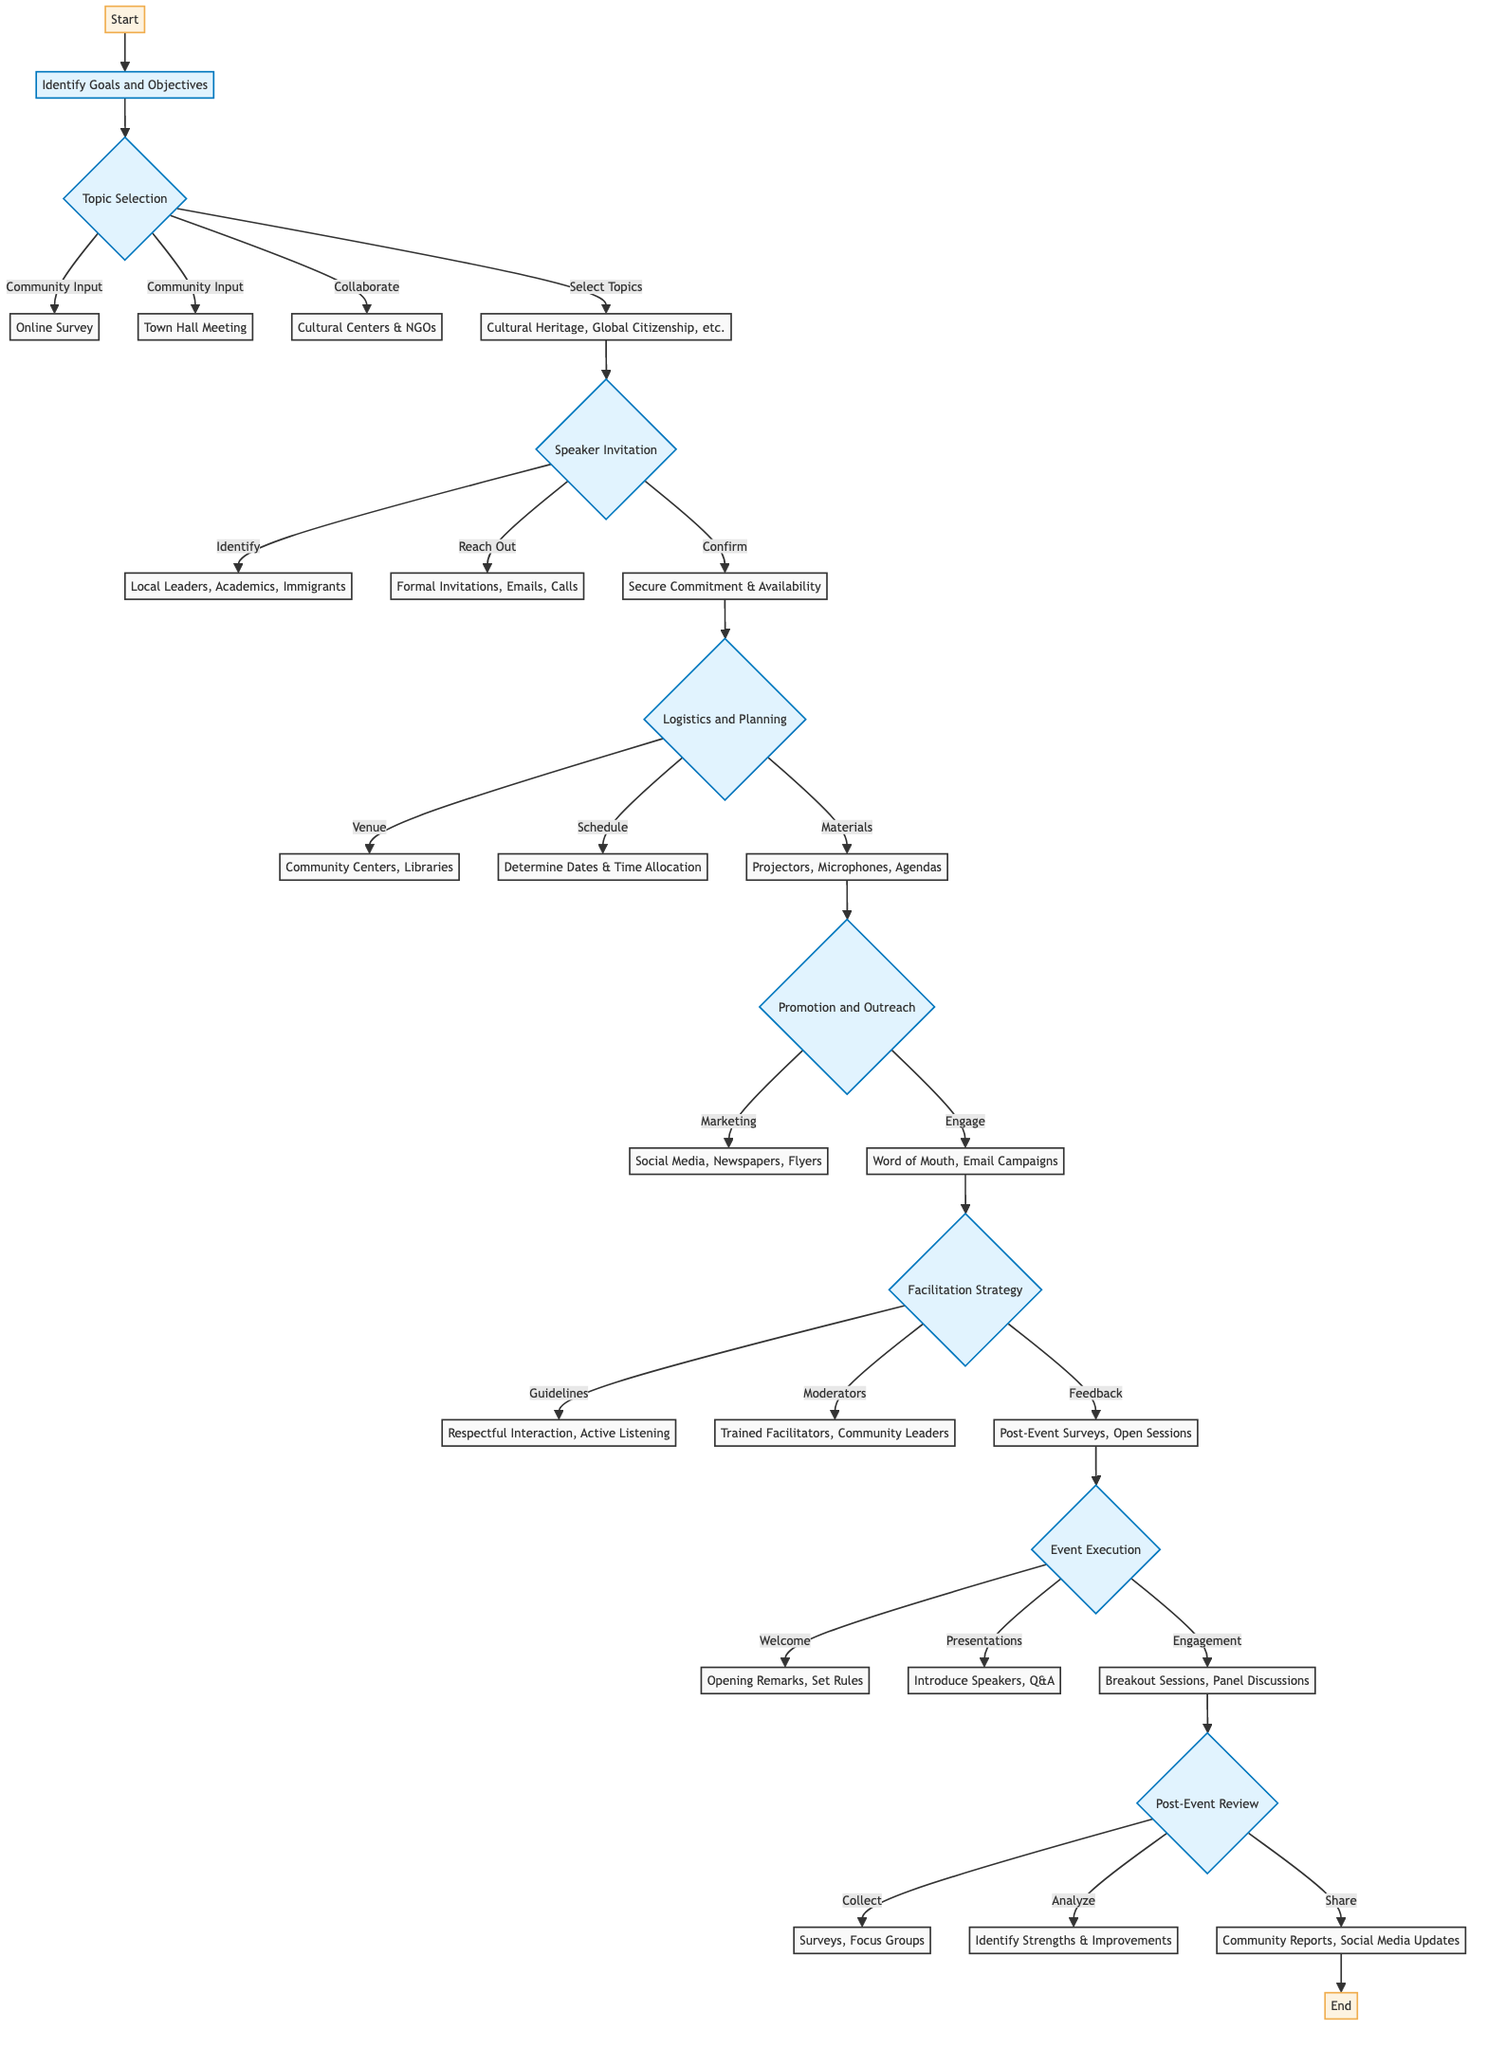What are the objectives of the dialogue series? The diagram indicates three objectives: Foster understanding, Encourage community participation, and Highlight diverse perspectives that need to be achieved.
Answer: Foster understanding, Encourage community participation, Highlight diverse perspectives How many community input methods are mentioned in the topic selection? The diagram shows two methods for community input: Online Survey and Town Hall Meeting, so the total count is two methods.
Answer: 2 What types of organizations should be collaborated with for topic selection? According to the diagram, the types of organizations include Cultural Centers and NGOs like Amnesty International and Red Cross, highlighting the importance of collaboration with these entities.
Answer: Cultural Centers & NGOs Which step comes after confirming the participation of speakers? After confirming the participation of speakers, the next step is logistics and planning, which includes determining various logistical aspects for the event.
Answer: Logistics and Planning What is the first activity listed in the event execution section? The first activity listed in the event execution section is Welcome and Introduction, focusing on opening remarks and setting the tone for the event.
Answer: Welcome and Introduction What are the methods for collecting feedback after the event? The diagram indicates that feedback can be collected using Surveys and Focus Groups, ensuring diverse perspectives are gathered from the participants after the event.
Answer: Surveys, Focus Groups How many marketing channels are mentioned in the promotion and outreach section? There are three marketing channels mentioned: Social Media, Local Newspapers, and Flyers, which are essential for reaching out to the community.
Answer: 3 What type of interaction is encouraged during the facilitation strategy? The facilitation strategy encourages Respectful Interaction, which is vital to ensure all participants feel included and valued during discussions.
Answer: Respectful Interaction Who is responsible for the moderation according to the facilitation strategy? The diagram indicates that trained facilitators and community leaders are responsible for the moderation of the discussions, helping to guide the dialogue effectively.
Answer: Trained Facilitators, Community Leaders 